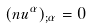Convert formula to latex. <formula><loc_0><loc_0><loc_500><loc_500>( n u ^ { \alpha } ) _ { ; \alpha } = 0</formula> 